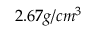<formula> <loc_0><loc_0><loc_500><loc_500>2 . 6 7 g / c m ^ { 3 }</formula> 